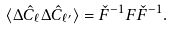<formula> <loc_0><loc_0><loc_500><loc_500>\langle \Delta \hat { C } _ { \ell } \Delta \hat { C } _ { \ell ^ { \prime } } \rangle = \check { F } ^ { - 1 } F \check { F } ^ { - 1 } .</formula> 